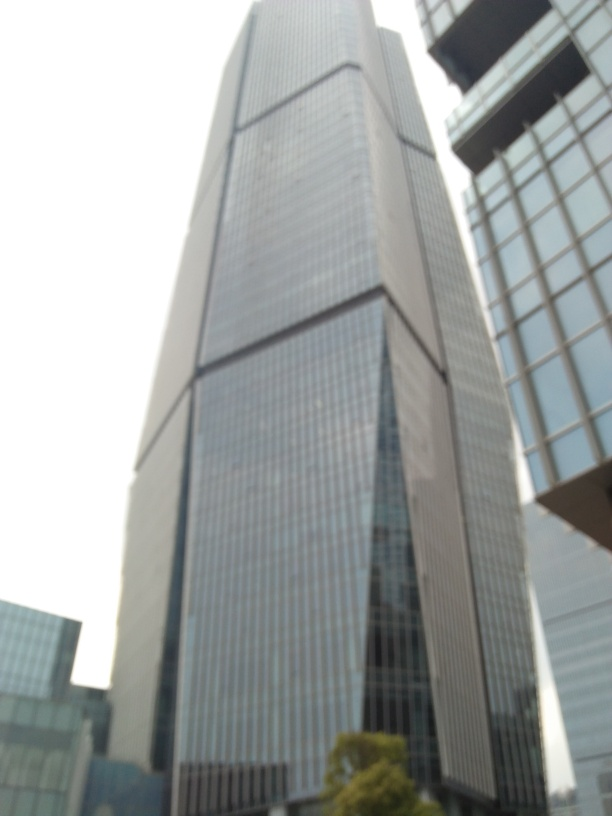Can you guess what the surrounding environment is like based on the image? Given the large scale of the building and the visible neighboring high-rises, it suggests an urban, likely downtown, setting. This is typically characterized by dense construction, limited green spaces, and a bustling atmosphere. Is there anything in the photo that indicates the possible location of this building? There are no distinct landmarks or signage visible in the photo that would pinpoint the exact location, but the modern high-rise architecture indicates it could be in a major city known for its skyscrapers, like those found in many global financial or business districts. 